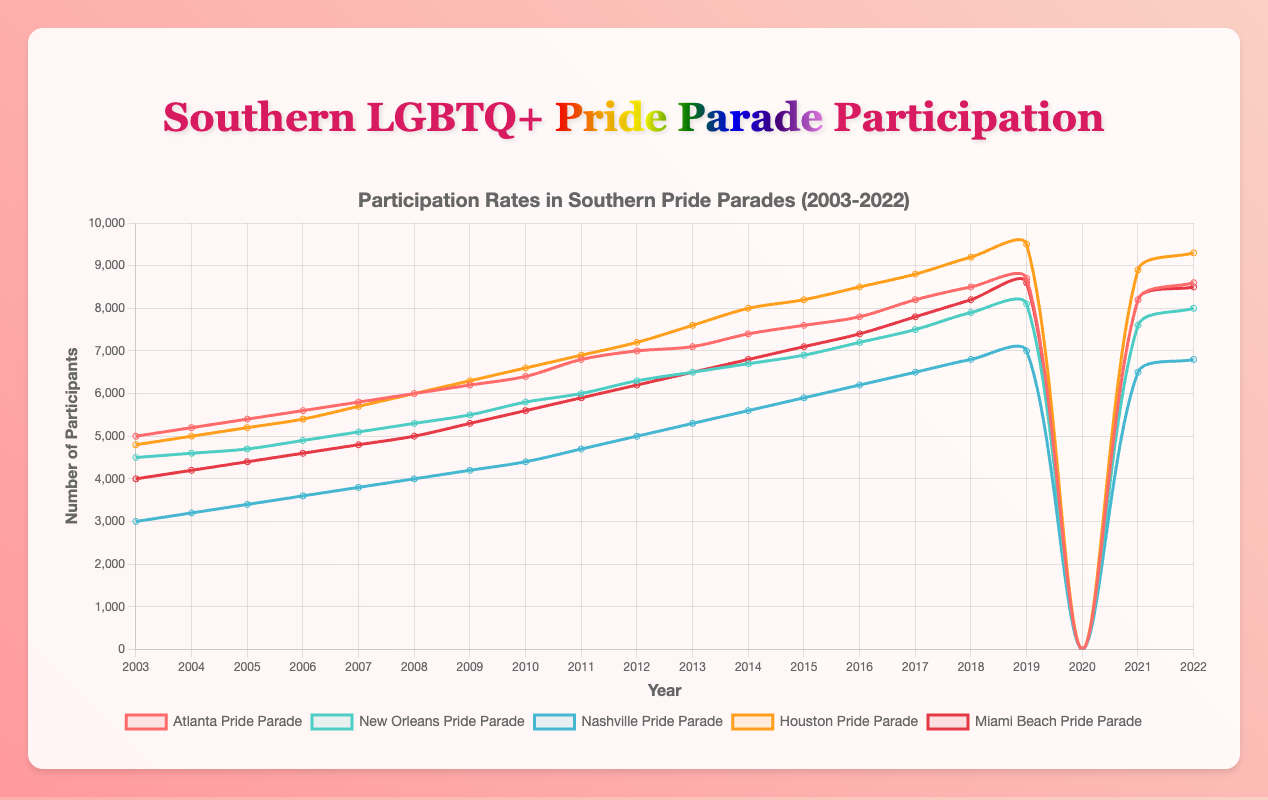What year did the Atlanta Pride Parade have the highest number of participants? Look at the line representing the Atlanta Pride Parade and find the peak value. It appears to be at the year 2019 with 8700 participants.
Answer: 2019 Which parade had more participants in 2015, the Nashville Pride Parade or the Miami Beach Pride Parade? Check both lines at the year 2015. Nashville had 6500 participants, while Miami Beach had 7800 participants.
Answer: Miami Beach Pride Parade How did the participation rate change in the Houston Pride Parade from 2010 to 2011? Look at the Houston Pride Parade data for 2010 and 2011. In 2010, there were 6600 participants, and in 2011, there were 6900 participants. The participation rate increased by 300.
Answer: Increased by 300 In which year did all the parades record zero participation rates? Refer to the lines and locate the year where all values are zero. This occurs in 2020.
Answer: 2020 Compare the participation in the New Orleans Pride Parade and the Houston Pride Parade in 2022. Which was higher? Look at the data for 2022 for both parades. New Orleans had 8000 participants, while Houston had 9300 participants. Houston's participation was higher.
Answer: Houston Pride Parade Which parade had the smallest number of participants in 2003? Check the values for each parade in 2003. The Nashville Pride Parade had the smallest with 3000 participants.
Answer: Nashville Pride Parade What is the total number of participants in the Miami Beach Pride Parade over the first decade (2003-2012)? Sum the participation values from 2003 to 2012 for Miami Beach: 4000 + 4200 + 4400 + 4600 + 4800 + 5000 + 5300 + 5600 + 5900 + 6200 = 50000.
Answer: 50000 How did the participation in the New Orleans and Nashville Pride Parades compare in 2016? Which parade had a greater increase since the previous year? Look at the data for 2015 and 2016 for both parades. New Orleans increased from 7200 to 7500 (increase of 300), and Nashville increased from 6200 to 6500 (increase of 300). Both had an equal increase.
Answer: Equal increase What is the average participation rate of the Atlanta Pride Parade from 2003 to 2022? First, find the sum of all participation rates from 2003 to 2022, excluding the zero value for 2020, as follows: 5000 + 5200 + 5400 + 5600 + 5800 + 6000 + 6200 + 6400 + 6800 + 7000 + 7100 + 7400 + 7600 + 7800 + 8200 + 8500 + 8700 + 8200 + 8600 = 139000. Divide this sum by 19 (years excluding 2020). 139000 / 19 = 7315.79.
Answer: 7316 What is the visual difference in the colors representing the Atlanta and Miami Beach Pride Parades? The line for the Atlanta Pride Parade is represented in red, while the Miami Beach Pride Parade is in a darker red shade.
Answer: Different shades of red 